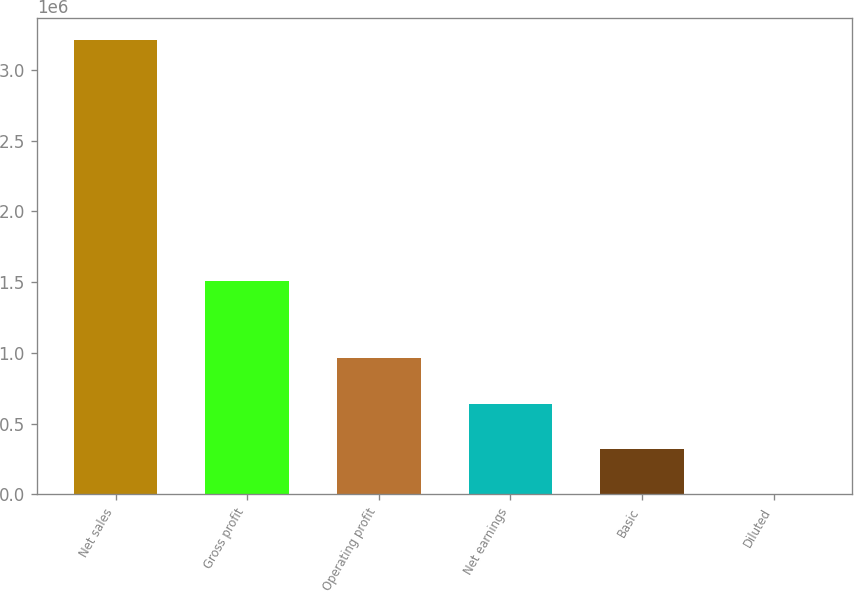<chart> <loc_0><loc_0><loc_500><loc_500><bar_chart><fcel>Net sales<fcel>Gross profit<fcel>Operating profit<fcel>Net earnings<fcel>Basic<fcel>Diluted<nl><fcel>3.20818e+06<fcel>1.51057e+06<fcel>962455<fcel>641637<fcel>320819<fcel>1.11<nl></chart> 